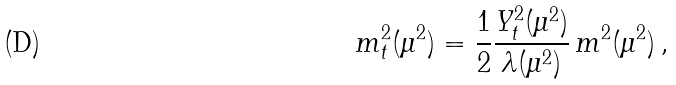<formula> <loc_0><loc_0><loc_500><loc_500>m _ { t } ^ { 2 } ( \mu ^ { 2 } ) = \frac { 1 } { 2 } \frac { Y ^ { 2 } _ { t } ( \mu ^ { 2 } ) } { \lambda ( \mu ^ { 2 } ) } \, m ^ { 2 } ( \mu ^ { 2 } ) \, ,</formula> 